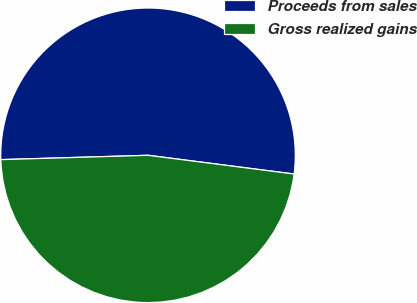<chart> <loc_0><loc_0><loc_500><loc_500><pie_chart><fcel>Proceeds from sales<fcel>Gross realized gains<nl><fcel>52.5%<fcel>47.5%<nl></chart> 